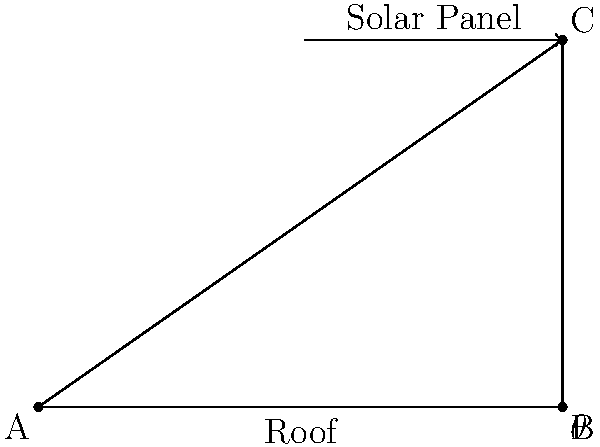As a project manager overseeing an HVAC installation that includes solar panels, you need to determine the optimal angle for the panels. The roof has a pitch of 35°, and the solar panel is 6 feet long. If the optimal angle for the solar panel is 10° greater than the roof pitch, what is the vertical height difference between the top and bottom of the solar panel? Round your answer to the nearest inch. To solve this problem, we'll follow these steps:

1) First, we need to determine the angle of the solar panel:
   Panel angle = Roof pitch + 10° = 35° + 10° = 45°

2) Now, we can use trigonometry to find the height difference. We'll use the sine function:
   $\sin(\theta) = \frac{\text{opposite}}{\text{hypotenuse}}$

3) In this case:
   $\theta = 45°$
   hypotenuse = length of the solar panel = 6 feet

4) We can rearrange the equation to solve for the opposite side (height difference):
   $\text{height} = 6 \times \sin(45°)$

5) $\sin(45°) = \frac{\sqrt{2}}{2} \approx 0.7071$

6) So, the height difference is:
   $6 \times 0.7071 = 4.2426$ feet

7) Converting to inches:
   $4.2426 \times 12 = 50.9112$ inches

8) Rounding to the nearest inch:
   51 inches
Answer: 51 inches 